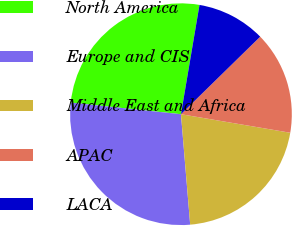<chart> <loc_0><loc_0><loc_500><loc_500><pie_chart><fcel>North America<fcel>Europe and CIS<fcel>Middle East and Africa<fcel>APAC<fcel>LACA<nl><fcel>26.0%<fcel>28.0%<fcel>21.0%<fcel>15.0%<fcel>10.0%<nl></chart> 